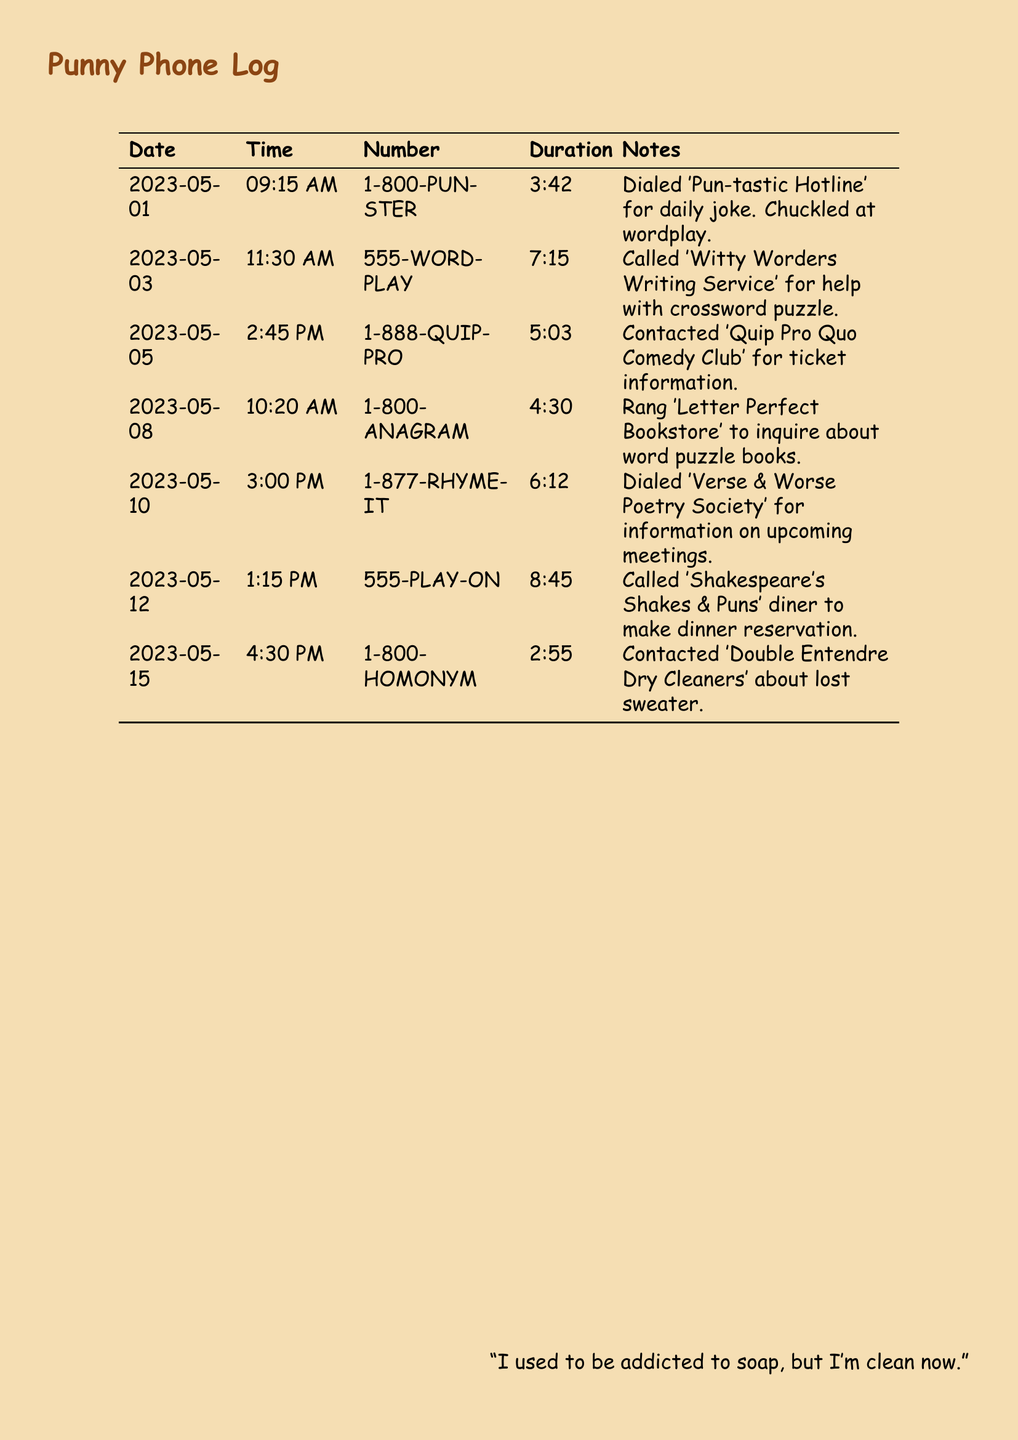What is the date of the first call? The first call in the log is documented under the date 2023-05-01.
Answer: 2023-05-01 What is the duration of the call to 1-800-PUN-STER? Referring to the log, the duration listed for the call to 1-800-PUN-STER is 3:42.
Answer: 3:42 Which hotline was called for joke assistance? The hotline dialed for joke assistance is referred to as 'Pun-tastic Hotline', indicated by the number 1-800-PUN-STER.
Answer: 1-800-PUN-STER How long was the call made to 555-PLAY-ON? The call to 555-PLAY-ON lasted for 8:45, as noted in the records.
Answer: 8:45 How many minutes long was the contact with 1-888-QUIP-PRO? The call made to 1-888-QUIP-PRO lasted 5:03, which represents the total duration for that entry.
Answer: 5:03 Which hotline helps with crosswords? The number associated with crossword puzzle assistance is 555-WORD-PLAY, indicating that it is the service used for that purpose.
Answer: 555-WORD-PLAY What is the main focus of the 'Verse & Worse Poetry Society'? According to the notes, the contact is made for information about upcoming meetings, reflecting the focus of the society.
Answer: Upcoming meetings Which business was contacted about a lost sweater? The hotline dedicated to lost sweater inquiries is connected with 'Double Entendre Dry Cleaners'.
Answer: Double Entendre Dry Cleaners How many calls are listed in total? By counting the entries, there are seven calls recorded in the log, noting the total number.
Answer: Seven 